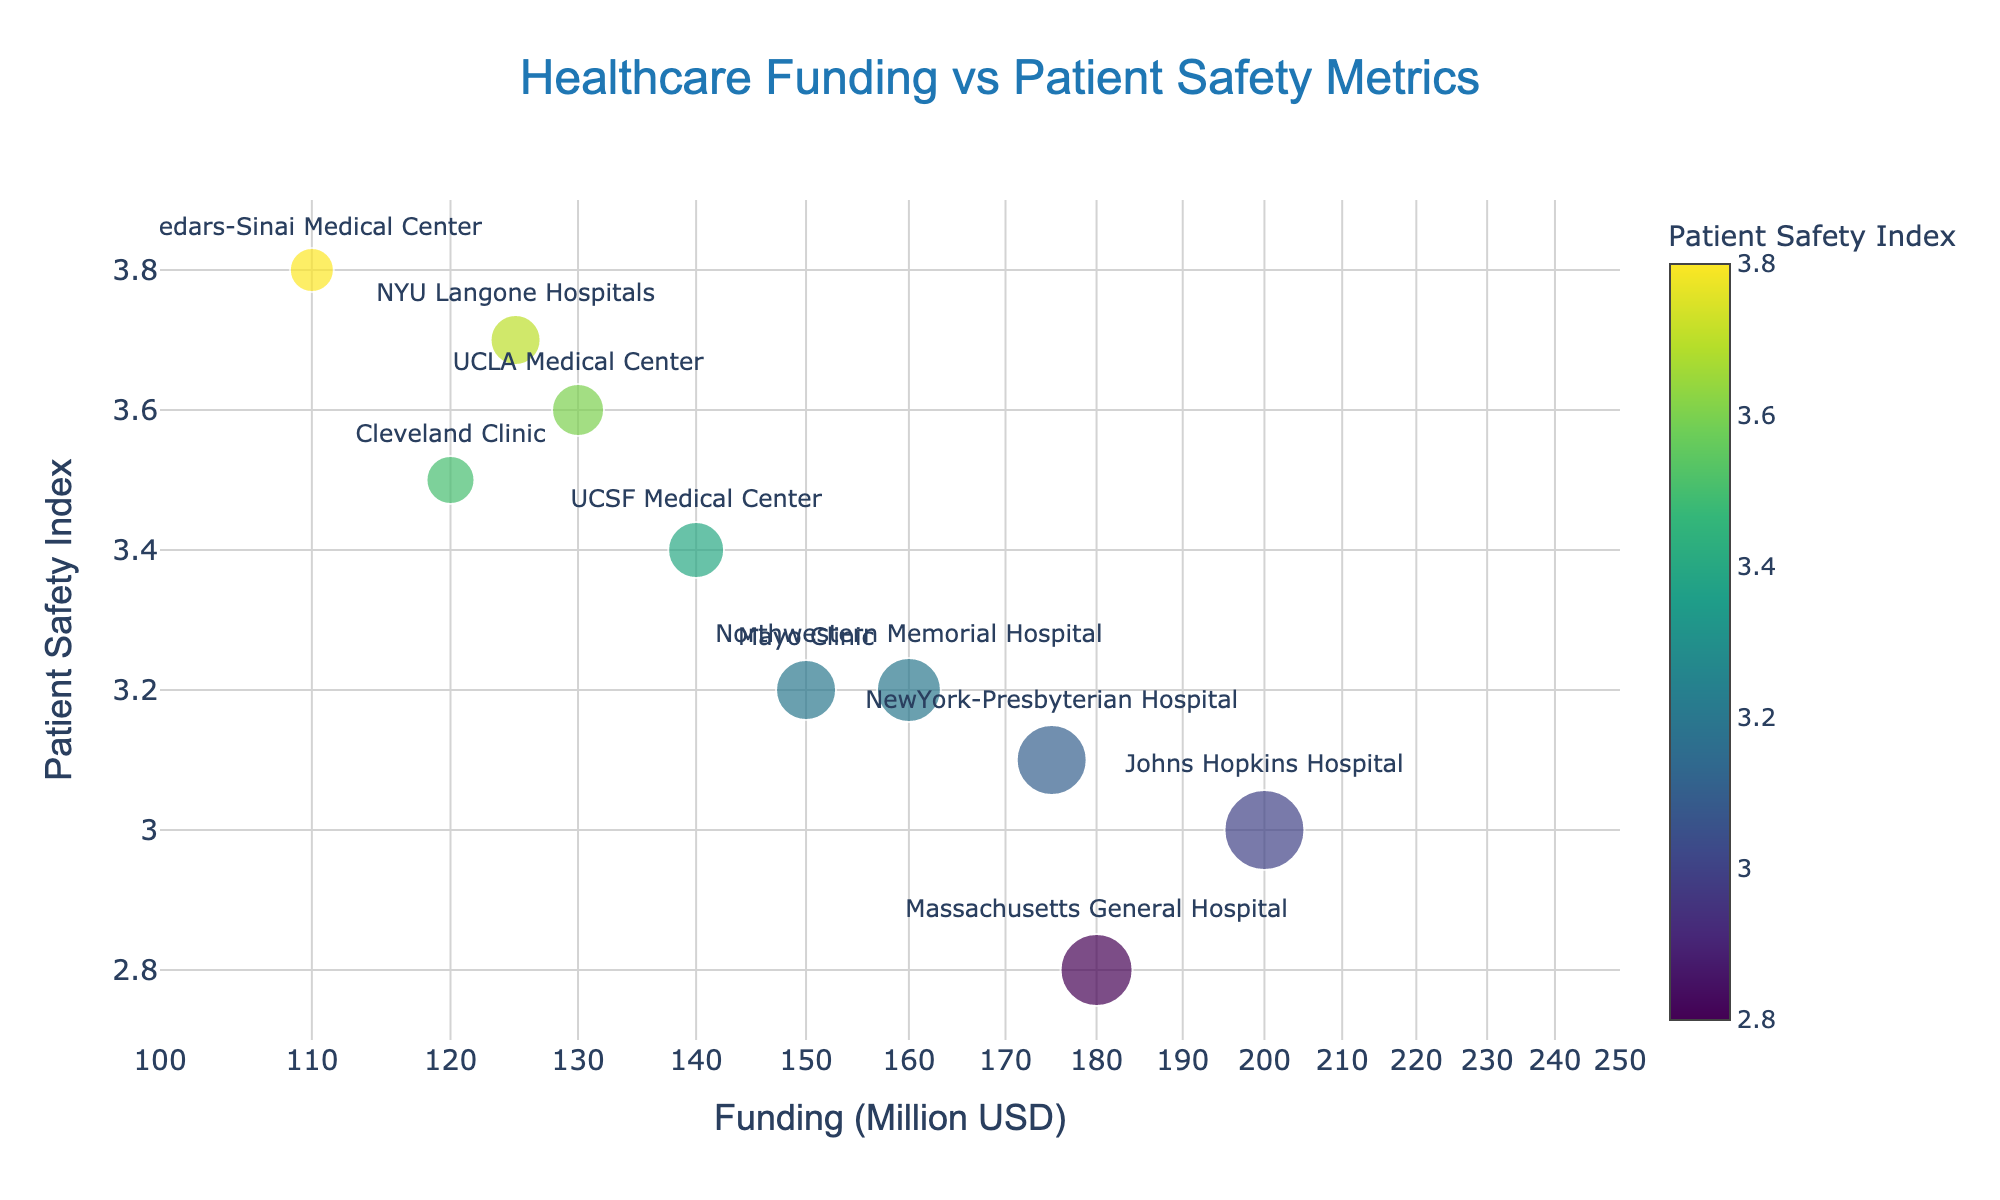What is the title of the plot? The title of the plot is prominently displayed at the top center of the figure. It provides a summary of the content, which helps in understanding the context and purpose of the visualization.
Answer: Healthcare Funding vs Patient Safety Metrics How many hospitals are represented in the plot? By counting the number of unique markers or hospital names on the plot, you can determine the total number of hospitals represented.
Answer: 10 Which hospital has the highest funding, and what is its Patient Safety Index? Look for the data point with the highest x-value on the log scale representing funding; hover over this point or refer to the text labels.
Answer: Johns Hopkins Hospital, 3.0 What is the Patient Safety Index range in the plot? By observing the y-axis, you can note the minimum and maximum values used for the Patient Safety Index.
Answer: 2.7 to 3.9 Which hospital has the smallest funding, and what is its Patient Safety Index? Identify the data point with the lowest x-value on the log scale; hover over it or refer to the text labels.
Answer: Cedars-Sinai Medical Center, 3.8 Calculate the average funding of the hospitals. Sum all the funding amounts and divide by the number of hospitals. (150 + 120 + 200 + 180 + 130 + 110 + 175 + 140 + 160 + 125) / 10 = 149.0
Answer: 149.0 Million USD Compare the Patient Safety Index of NYU Langone Hospitals and Cleveland Clinic. Which one is higher? Locate the points for NYU Langone Hospitals and Cleveland Clinic on the plot and compare their y-values on the axis.
Answer: NYU Langone Hospitals Is there a general trend observed between funding and Patient Safety Index? Observe the overall distribution and pattern of the data points to identify if an increase in funding tends to associate with higher or lower Safety Index.
Answer: No clear trend What is the range of the funding displayed on the log axis? Check the x-axis labels to determine the span of funding values presented in the log scale. The range [100, 250] can be translated to the actual range, which spans from 100 Million USD to just below 250 Million USD.
Answer: 100 - 250 Million USD Do hospitals with higher funding generally have better (higher) Patient Safety Index in this plot? By analyzing the location and color of the markers, you can determine if there's a positive correlation between higher funding and better Safety Index.
Answer: No 